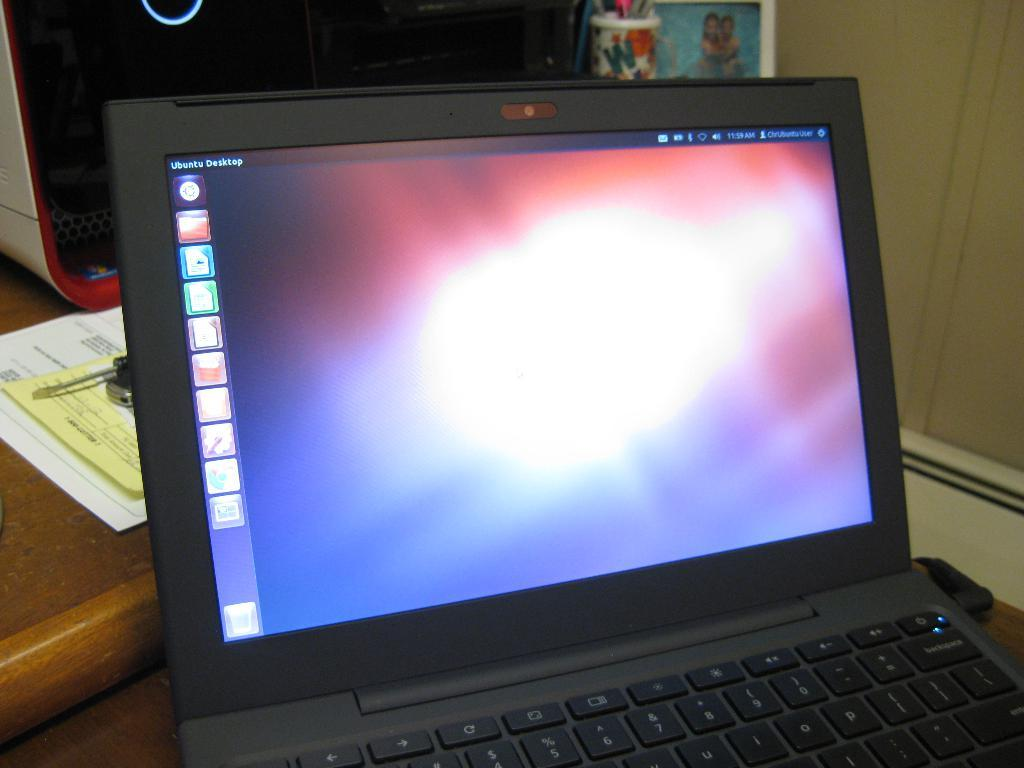<image>
Provide a brief description of the given image. A laptop that has Ubuntu Desktop displayed on its taskbar. 